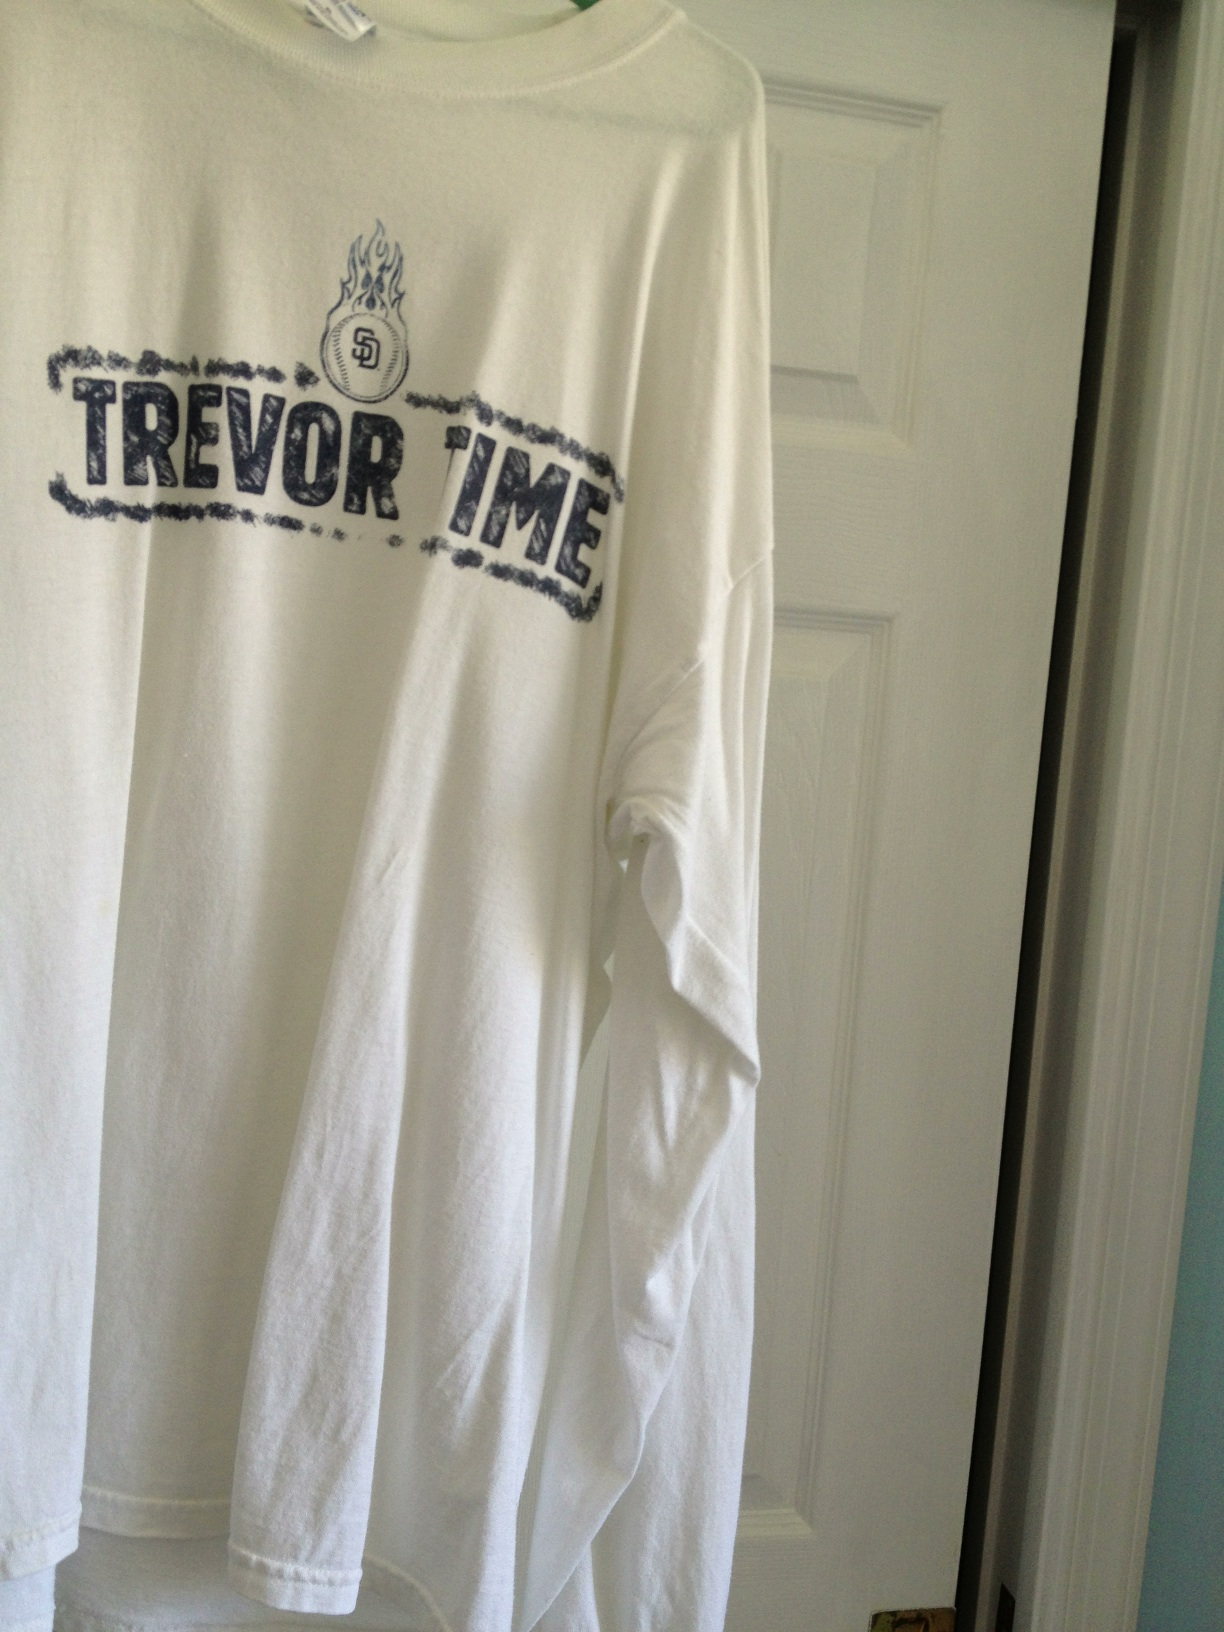What are some potential scenarios where this shirt might be worn? In a long response: This shirt might be worn during a chilly evening game at the stadium, where fans gather to support Trevor and the Padres. It's also perfect for reunions of old friends reminiscing about legendary games and key moments in baseball history. Furthermore, one might wear it to a casual gathering or barbecue where fellow fans congregate, sharing stories and spirited conversations about their favorite matches and players. Can you provide a realistic short scenario too? Sure! The shirt could be worn while running errands around the city, proudly displaying one's loyalty to the Padres and sparking brief but passionate discussions with fellow fans encountered along the way. 